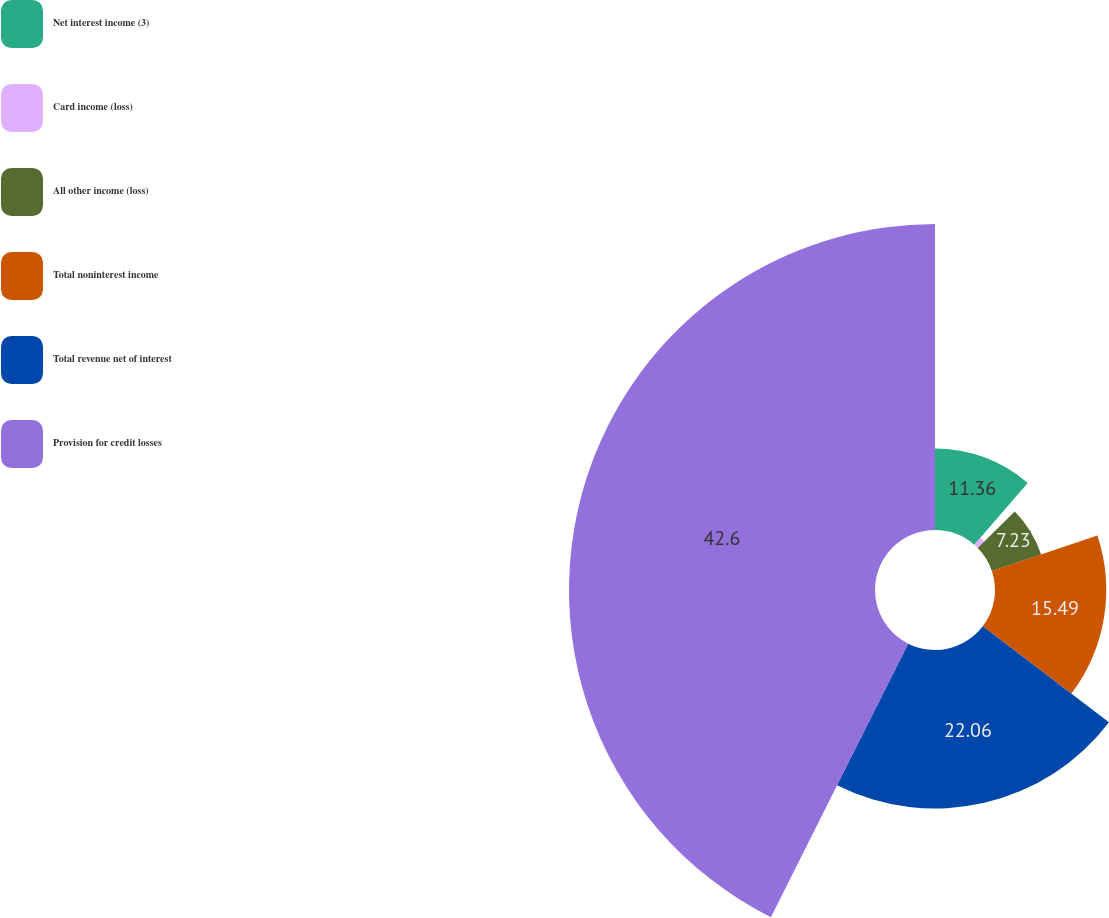Convert chart to OTSL. <chart><loc_0><loc_0><loc_500><loc_500><pie_chart><fcel>Net interest income (3)<fcel>Card income (loss)<fcel>All other income (loss)<fcel>Total noninterest income<fcel>Total revenue net of interest<fcel>Provision for credit losses<nl><fcel>11.36%<fcel>1.26%<fcel>7.23%<fcel>15.49%<fcel>22.06%<fcel>42.6%<nl></chart> 